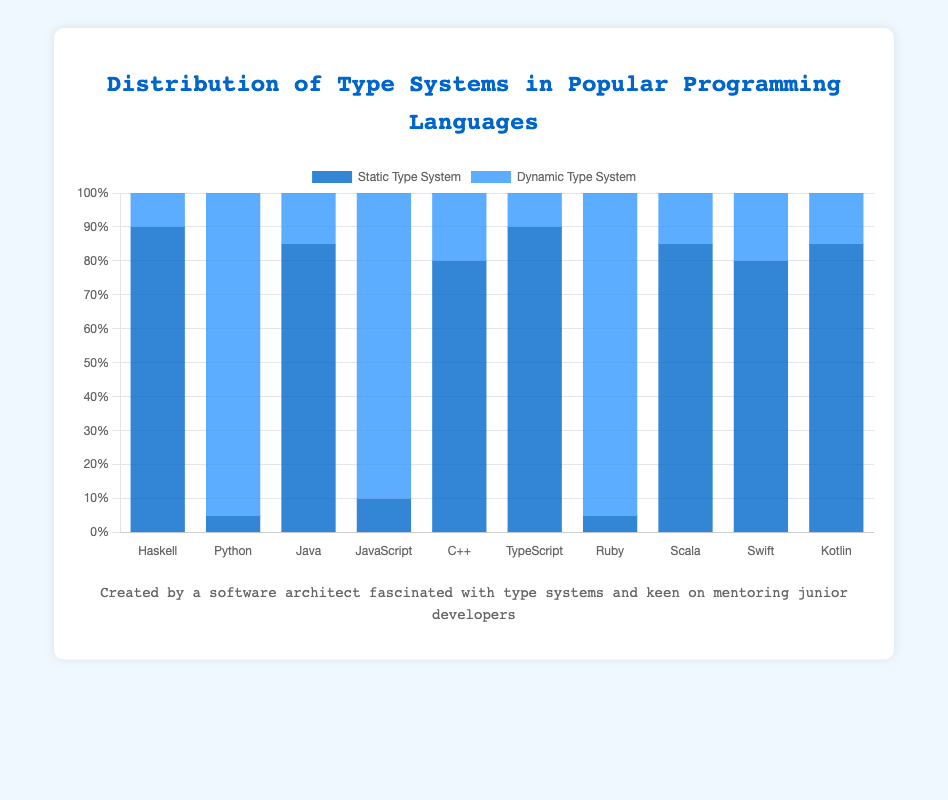Which language has the highest percentage of a static type system? Look at the blue bars representing the static type systems and compare their heights. Haskell and TypeScript both reach the top of their respective sections at 90%. Additionally, Java and Scala have high percentages at 85%, but Haskell and TypeScript are still higher.
Answer: Haskell and TypeScript Which language has the lowest percentage of dynamic type systems? Look at the dark blue bars representing dynamic type systems and find the shortest one. Haskell and TypeScript both have the lowest at 10%.
Answer: Haskell and TypeScript What is the difference in the percentage of static type systems between Java and Python? Java has an 85% static type system. Python has a 5% static type system. The difference is calculated as 85 - 5.
Answer: 80% Which languages have an equal distribution between static and dynamic type systems? None of the bars are exactly 50% in height for both static and dynamic type systems, meaning no language has an equal distribution.
Answer: None How many languages have a greater percentage of dynamic type systems than static type systems? For each language, compare the dark blue bar (dynamic) with the blue bar (static). Python, JavaScript, and Ruby show higher percentages of dynamic type systems than static type systems.
Answer: 3 What is the average percentage of static type systems in Haskell, TypeScript, and Scala? Haskell, TypeScript, and Scala have static type system percentages of 90, 90, and 85 respectively. The average is calculated as (90 + 90 + 85) / 3.
Answer: 88.33% Between JavaScript and Python, which one has a higher percentage of dynamic type systems? Compare the dark blue bars for JavaScript and Python. JavaScript has 90% while Python has 95%, so Python has a higher percentage.
Answer: Python Which languages have a static type system percentage equal to or above 80%? Identify the blue bars with heights starting from 80% and above. These languages are Haskell, Java, C++, TypeScript, Scala, Swift, and Kotlin.
Answer: Haskell, Java, C++, TypeScript, Scala, Swift, and Kotlin What is the combined percentage of static type systems for C++ and Swift? C++ has 80% static type system, and Swift also has 80%. The combined percentage is 80 + 80.
Answer: 160% Between Ruby and Python, which one has a lower percentage of static type systems? Compare the blue bars for Ruby and Python. Ruby has 5% and Python also has 5%, so they are equal.
Answer: Both have 5% 